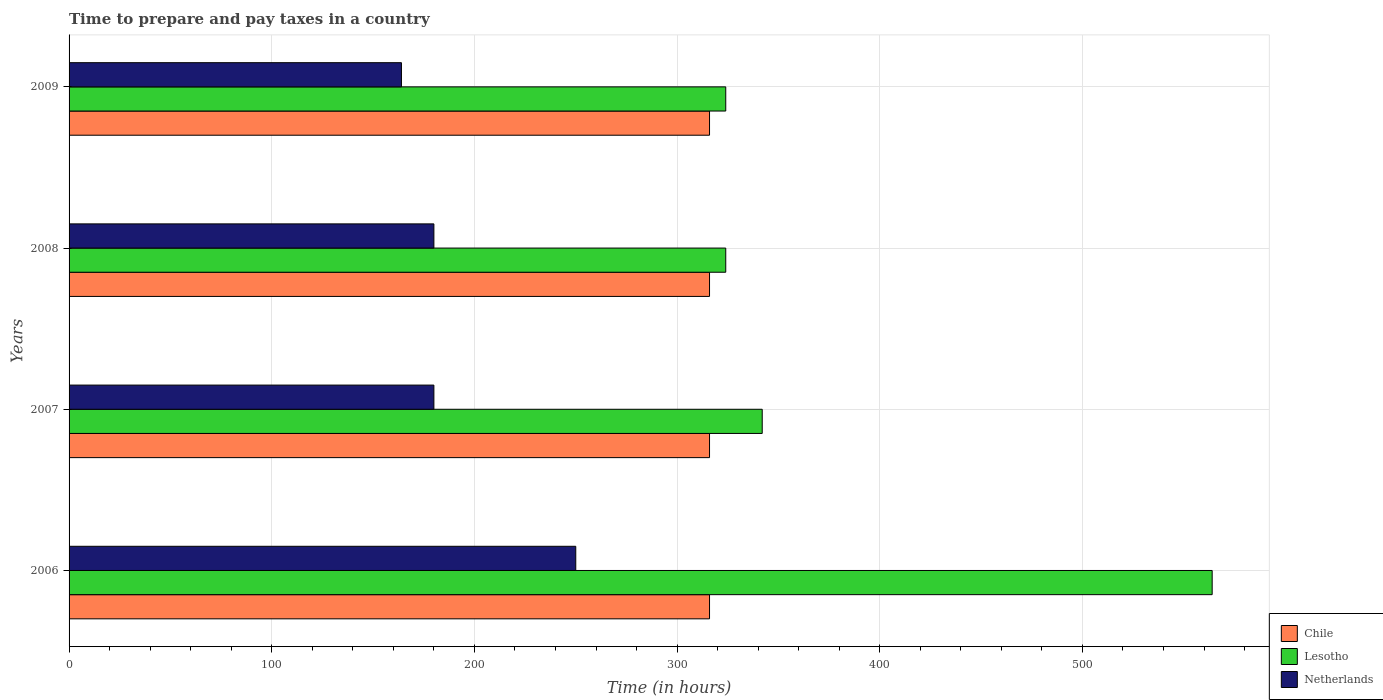Are the number of bars on each tick of the Y-axis equal?
Your answer should be compact. Yes. How many bars are there on the 2nd tick from the top?
Provide a short and direct response. 3. How many bars are there on the 3rd tick from the bottom?
Give a very brief answer. 3. What is the number of hours required to prepare and pay taxes in Chile in 2006?
Ensure brevity in your answer.  316. Across all years, what is the maximum number of hours required to prepare and pay taxes in Netherlands?
Provide a succinct answer. 250. Across all years, what is the minimum number of hours required to prepare and pay taxes in Lesotho?
Keep it short and to the point. 324. In which year was the number of hours required to prepare and pay taxes in Netherlands maximum?
Your answer should be compact. 2006. In which year was the number of hours required to prepare and pay taxes in Chile minimum?
Keep it short and to the point. 2006. What is the total number of hours required to prepare and pay taxes in Lesotho in the graph?
Offer a very short reply. 1554. What is the difference between the number of hours required to prepare and pay taxes in Netherlands in 2006 and that in 2009?
Give a very brief answer. 86. What is the average number of hours required to prepare and pay taxes in Lesotho per year?
Offer a very short reply. 388.5. In the year 2009, what is the difference between the number of hours required to prepare and pay taxes in Netherlands and number of hours required to prepare and pay taxes in Lesotho?
Provide a succinct answer. -160. In how many years, is the number of hours required to prepare and pay taxes in Chile greater than 340 hours?
Your answer should be very brief. 0. Is the number of hours required to prepare and pay taxes in Netherlands in 2006 less than that in 2009?
Make the answer very short. No. Is the difference between the number of hours required to prepare and pay taxes in Netherlands in 2006 and 2009 greater than the difference between the number of hours required to prepare and pay taxes in Lesotho in 2006 and 2009?
Offer a very short reply. No. What is the difference between the highest and the second highest number of hours required to prepare and pay taxes in Chile?
Your answer should be very brief. 0. What is the difference between the highest and the lowest number of hours required to prepare and pay taxes in Netherlands?
Your response must be concise. 86. Is the sum of the number of hours required to prepare and pay taxes in Netherlands in 2007 and 2009 greater than the maximum number of hours required to prepare and pay taxes in Chile across all years?
Your answer should be compact. Yes. What does the 2nd bar from the top in 2006 represents?
Keep it short and to the point. Lesotho. What does the 1st bar from the bottom in 2008 represents?
Ensure brevity in your answer.  Chile. How many years are there in the graph?
Provide a succinct answer. 4. Does the graph contain grids?
Ensure brevity in your answer.  Yes. How are the legend labels stacked?
Your answer should be compact. Vertical. What is the title of the graph?
Your answer should be very brief. Time to prepare and pay taxes in a country. What is the label or title of the X-axis?
Your answer should be very brief. Time (in hours). What is the label or title of the Y-axis?
Offer a very short reply. Years. What is the Time (in hours) in Chile in 2006?
Offer a terse response. 316. What is the Time (in hours) of Lesotho in 2006?
Your response must be concise. 564. What is the Time (in hours) in Netherlands in 2006?
Your answer should be very brief. 250. What is the Time (in hours) in Chile in 2007?
Your answer should be very brief. 316. What is the Time (in hours) of Lesotho in 2007?
Provide a succinct answer. 342. What is the Time (in hours) in Netherlands in 2007?
Your response must be concise. 180. What is the Time (in hours) of Chile in 2008?
Keep it short and to the point. 316. What is the Time (in hours) in Lesotho in 2008?
Give a very brief answer. 324. What is the Time (in hours) of Netherlands in 2008?
Give a very brief answer. 180. What is the Time (in hours) of Chile in 2009?
Your answer should be very brief. 316. What is the Time (in hours) of Lesotho in 2009?
Give a very brief answer. 324. What is the Time (in hours) in Netherlands in 2009?
Your answer should be compact. 164. Across all years, what is the maximum Time (in hours) of Chile?
Your response must be concise. 316. Across all years, what is the maximum Time (in hours) in Lesotho?
Keep it short and to the point. 564. Across all years, what is the maximum Time (in hours) in Netherlands?
Your answer should be compact. 250. Across all years, what is the minimum Time (in hours) of Chile?
Offer a terse response. 316. Across all years, what is the minimum Time (in hours) of Lesotho?
Your response must be concise. 324. Across all years, what is the minimum Time (in hours) in Netherlands?
Your answer should be very brief. 164. What is the total Time (in hours) in Chile in the graph?
Ensure brevity in your answer.  1264. What is the total Time (in hours) of Lesotho in the graph?
Ensure brevity in your answer.  1554. What is the total Time (in hours) of Netherlands in the graph?
Offer a terse response. 774. What is the difference between the Time (in hours) of Lesotho in 2006 and that in 2007?
Provide a short and direct response. 222. What is the difference between the Time (in hours) of Lesotho in 2006 and that in 2008?
Provide a short and direct response. 240. What is the difference between the Time (in hours) of Netherlands in 2006 and that in 2008?
Your response must be concise. 70. What is the difference between the Time (in hours) in Chile in 2006 and that in 2009?
Provide a short and direct response. 0. What is the difference between the Time (in hours) in Lesotho in 2006 and that in 2009?
Your answer should be very brief. 240. What is the difference between the Time (in hours) in Netherlands in 2007 and that in 2008?
Offer a very short reply. 0. What is the difference between the Time (in hours) in Chile in 2007 and that in 2009?
Ensure brevity in your answer.  0. What is the difference between the Time (in hours) of Chile in 2006 and the Time (in hours) of Lesotho in 2007?
Make the answer very short. -26. What is the difference between the Time (in hours) in Chile in 2006 and the Time (in hours) in Netherlands in 2007?
Offer a very short reply. 136. What is the difference between the Time (in hours) of Lesotho in 2006 and the Time (in hours) of Netherlands in 2007?
Provide a succinct answer. 384. What is the difference between the Time (in hours) in Chile in 2006 and the Time (in hours) in Lesotho in 2008?
Ensure brevity in your answer.  -8. What is the difference between the Time (in hours) in Chile in 2006 and the Time (in hours) in Netherlands in 2008?
Offer a very short reply. 136. What is the difference between the Time (in hours) in Lesotho in 2006 and the Time (in hours) in Netherlands in 2008?
Provide a succinct answer. 384. What is the difference between the Time (in hours) of Chile in 2006 and the Time (in hours) of Lesotho in 2009?
Provide a short and direct response. -8. What is the difference between the Time (in hours) of Chile in 2006 and the Time (in hours) of Netherlands in 2009?
Your response must be concise. 152. What is the difference between the Time (in hours) in Lesotho in 2006 and the Time (in hours) in Netherlands in 2009?
Your answer should be very brief. 400. What is the difference between the Time (in hours) of Chile in 2007 and the Time (in hours) of Netherlands in 2008?
Make the answer very short. 136. What is the difference between the Time (in hours) of Lesotho in 2007 and the Time (in hours) of Netherlands in 2008?
Offer a very short reply. 162. What is the difference between the Time (in hours) of Chile in 2007 and the Time (in hours) of Netherlands in 2009?
Offer a terse response. 152. What is the difference between the Time (in hours) in Lesotho in 2007 and the Time (in hours) in Netherlands in 2009?
Provide a short and direct response. 178. What is the difference between the Time (in hours) in Chile in 2008 and the Time (in hours) in Lesotho in 2009?
Provide a succinct answer. -8. What is the difference between the Time (in hours) of Chile in 2008 and the Time (in hours) of Netherlands in 2009?
Offer a terse response. 152. What is the difference between the Time (in hours) in Lesotho in 2008 and the Time (in hours) in Netherlands in 2009?
Ensure brevity in your answer.  160. What is the average Time (in hours) of Chile per year?
Give a very brief answer. 316. What is the average Time (in hours) in Lesotho per year?
Provide a succinct answer. 388.5. What is the average Time (in hours) of Netherlands per year?
Your response must be concise. 193.5. In the year 2006, what is the difference between the Time (in hours) in Chile and Time (in hours) in Lesotho?
Provide a succinct answer. -248. In the year 2006, what is the difference between the Time (in hours) of Lesotho and Time (in hours) of Netherlands?
Keep it short and to the point. 314. In the year 2007, what is the difference between the Time (in hours) in Chile and Time (in hours) in Netherlands?
Your response must be concise. 136. In the year 2007, what is the difference between the Time (in hours) of Lesotho and Time (in hours) of Netherlands?
Make the answer very short. 162. In the year 2008, what is the difference between the Time (in hours) of Chile and Time (in hours) of Netherlands?
Make the answer very short. 136. In the year 2008, what is the difference between the Time (in hours) of Lesotho and Time (in hours) of Netherlands?
Offer a terse response. 144. In the year 2009, what is the difference between the Time (in hours) in Chile and Time (in hours) in Lesotho?
Give a very brief answer. -8. In the year 2009, what is the difference between the Time (in hours) in Chile and Time (in hours) in Netherlands?
Make the answer very short. 152. In the year 2009, what is the difference between the Time (in hours) of Lesotho and Time (in hours) of Netherlands?
Give a very brief answer. 160. What is the ratio of the Time (in hours) of Lesotho in 2006 to that in 2007?
Ensure brevity in your answer.  1.65. What is the ratio of the Time (in hours) of Netherlands in 2006 to that in 2007?
Ensure brevity in your answer.  1.39. What is the ratio of the Time (in hours) in Lesotho in 2006 to that in 2008?
Provide a succinct answer. 1.74. What is the ratio of the Time (in hours) of Netherlands in 2006 to that in 2008?
Make the answer very short. 1.39. What is the ratio of the Time (in hours) of Lesotho in 2006 to that in 2009?
Your response must be concise. 1.74. What is the ratio of the Time (in hours) in Netherlands in 2006 to that in 2009?
Provide a short and direct response. 1.52. What is the ratio of the Time (in hours) in Lesotho in 2007 to that in 2008?
Make the answer very short. 1.06. What is the ratio of the Time (in hours) of Lesotho in 2007 to that in 2009?
Offer a very short reply. 1.06. What is the ratio of the Time (in hours) in Netherlands in 2007 to that in 2009?
Provide a short and direct response. 1.1. What is the ratio of the Time (in hours) of Lesotho in 2008 to that in 2009?
Your response must be concise. 1. What is the ratio of the Time (in hours) of Netherlands in 2008 to that in 2009?
Your answer should be compact. 1.1. What is the difference between the highest and the second highest Time (in hours) in Lesotho?
Make the answer very short. 222. What is the difference between the highest and the second highest Time (in hours) of Netherlands?
Keep it short and to the point. 70. What is the difference between the highest and the lowest Time (in hours) in Chile?
Your answer should be very brief. 0. What is the difference between the highest and the lowest Time (in hours) of Lesotho?
Your answer should be very brief. 240. What is the difference between the highest and the lowest Time (in hours) of Netherlands?
Your response must be concise. 86. 